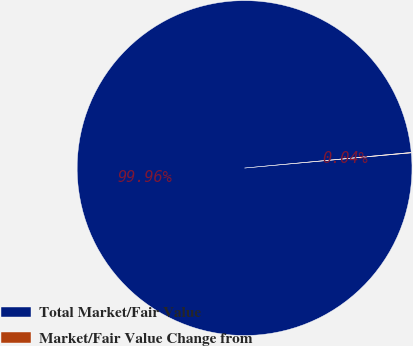Convert chart. <chart><loc_0><loc_0><loc_500><loc_500><pie_chart><fcel>Total Market/Fair Value<fcel>Market/Fair Value Change from<nl><fcel>99.96%<fcel>0.04%<nl></chart> 